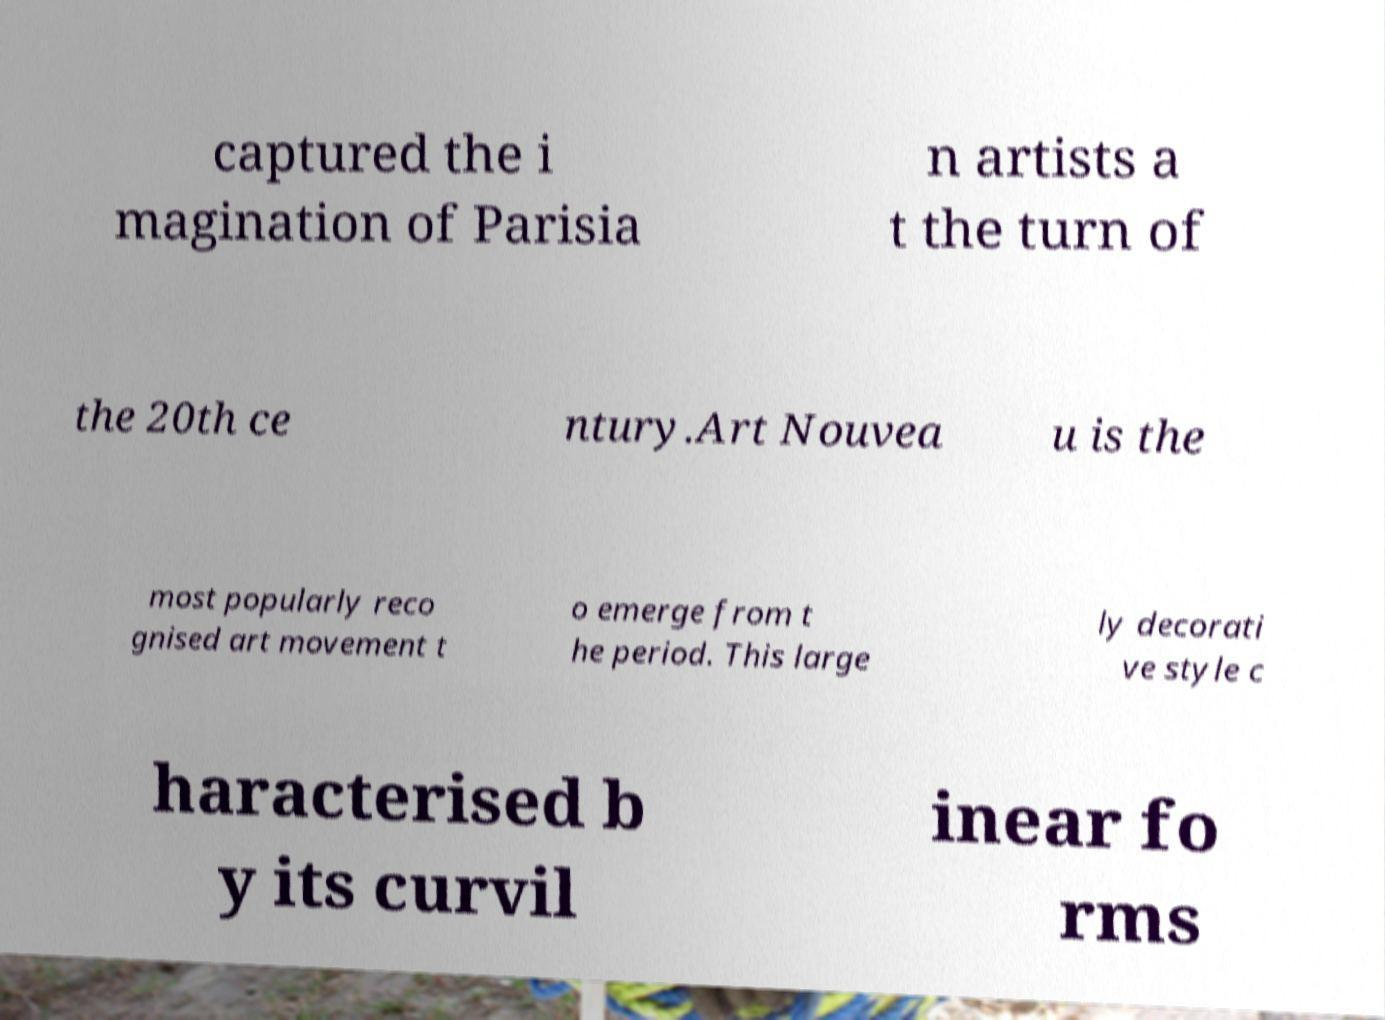Please read and relay the text visible in this image. What does it say? captured the i magination of Parisia n artists a t the turn of the 20th ce ntury.Art Nouvea u is the most popularly reco gnised art movement t o emerge from t he period. This large ly decorati ve style c haracterised b y its curvil inear fo rms 